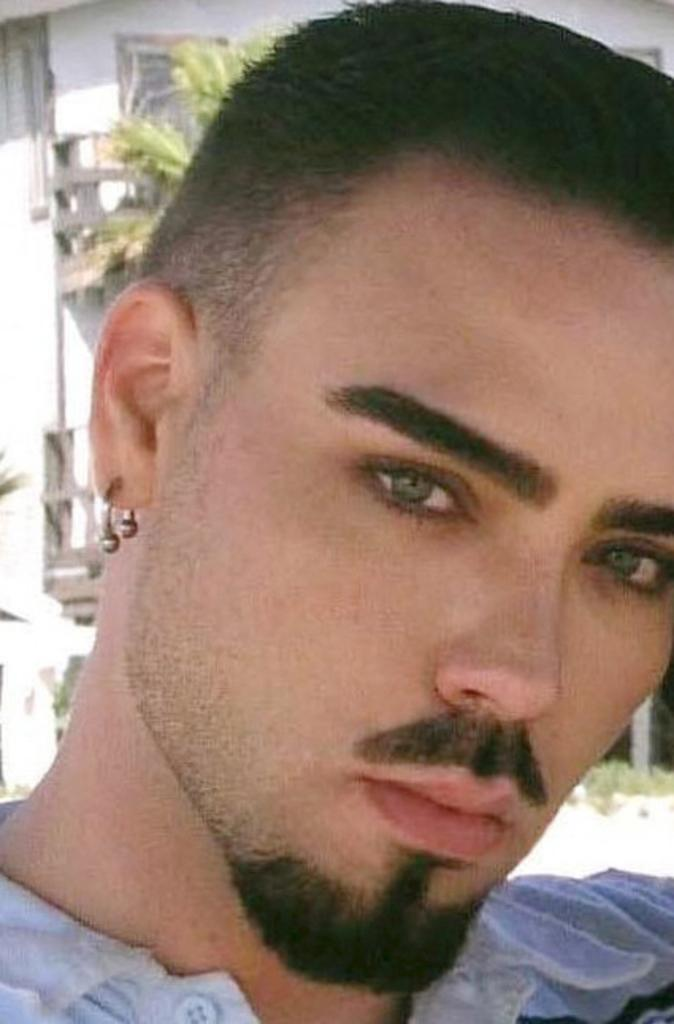Who is the main subject in the image? There is a man in the center of the image. What can be seen in the background of the image? There is a building and a tree visible in the background of the image. What type of boot is the man wearing in the image? The image does not show the man wearing any boots, so it is not possible to determine the type of boot he might be wearing. 